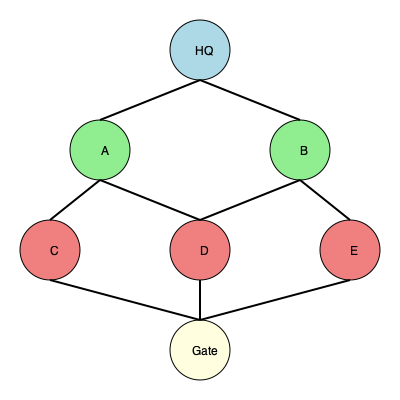Given the graph representation of a military base layout, where each node represents a key facility and edges represent possible patrol routes, determine the minimum number of edges that must be traversed to patrol all facilities starting from HQ and ending at the Gate. Assume each edge can only be traversed once, and all facilities must be visited. To solve this problem, we can use a modified version of the Euler path algorithm, as we need to visit all nodes (facilities) while minimizing the number of edge traversals.

Step 1: Identify the number of nodes with odd degree.
- HQ: degree 2 (even)
- A: degree 3 (odd)
- B: degree 3 (odd)
- C: degree 2 (even)
- D: degree 3 (odd)
- E: degree 2 (even)
- Gate: degree 3 (odd)

There are 4 nodes with odd degree: A, B, D, and Gate.

Step 2: For an Euler path to exist, there should be either 0 or 2 nodes with odd degree. Since we have 4, we need to add 2 imaginary edges to make it possible.

Step 3: The minimum number of edges to traverse all facilities is equal to the total number of edges in the graph plus the number of imaginary edges needed.

Total edges in the graph: 9
Imaginary edges needed: 2
Minimum number of edges to traverse: 9 + 2 = 11

Step 4: Verify that this solution visits all nodes:
A possible path: HQ -> A -> C -> Gate -> E -> B -> D -> Gate

This path traverses 11 edges (including 2 imaginary edges) and visits all facilities.
Answer: 11 edges 